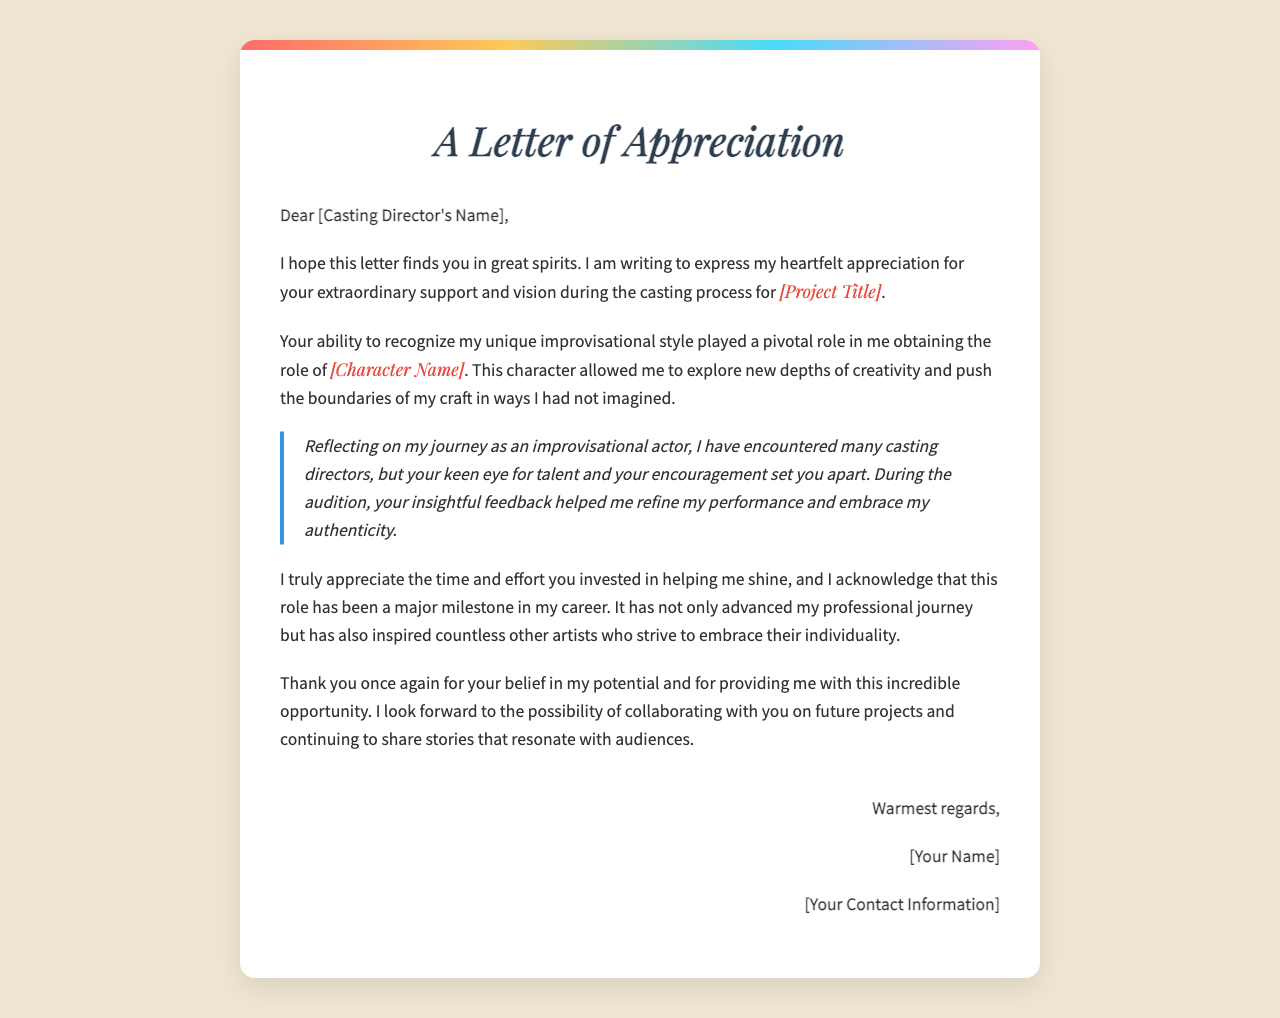What is the title of the project mentioned? The title of the project is indicated by the placeholder in the letter, which the writer acknowledges as pivotal in their career.
Answer: [Project Title] Who is being addressed in the letter? The letter is addressed to the casting director, whose name is specified in the salutation.
Answer: [Casting Director's Name] What role did the author obtain? The author highlights the character they portrayed as a significant achievement, showcasing their unique style.
Answer: [Character Name] What emotion does the author express in the letter? The author conveys heartfelt appreciation for the support and vision received from the casting director.
Answer: Appreciation What does the author hope for in the future? At the end of the letter, the author expresses a desire to collaborate with the casting director on more projects.
Answer: Collaborating on future projects What helped the author refine their performance? The letter mentions specific insightful feedback from the casting director that contributed to the author's performance.
Answer: Insightful feedback What impact did the role have on the author's career? The author describes this role as a major milestone that inspired both their journey and others in the industry.
Answer: Major milestone What style is the author known for? The document highlights the author's specific improvisational style that was recognized during the casting process.
Answer: Unique improvisational style What is included in the signature section? The signature section contains closing remarks and the author's name along with contact information.
Answer: [Your Name], [Your Contact Information] 